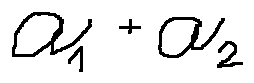Convert formula to latex. <formula><loc_0><loc_0><loc_500><loc_500>a _ { 1 } + a _ { 2 }</formula> 